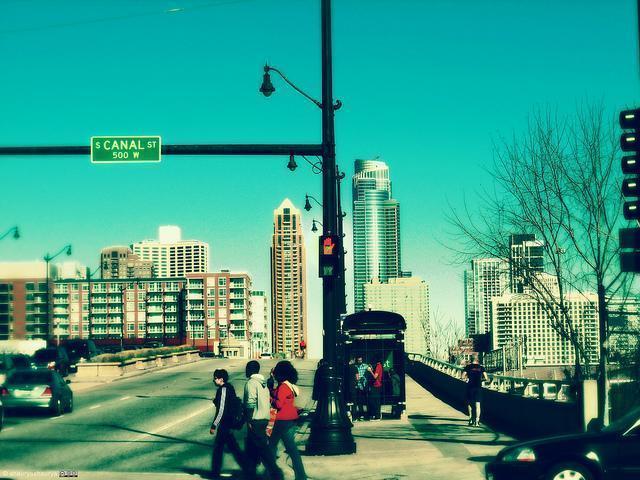What is the hand on the traffic light telling those facing it?
Indicate the correct response by choosing from the four available options to answer the question.
Options: Go left, walk, go right, stop. Stop. 